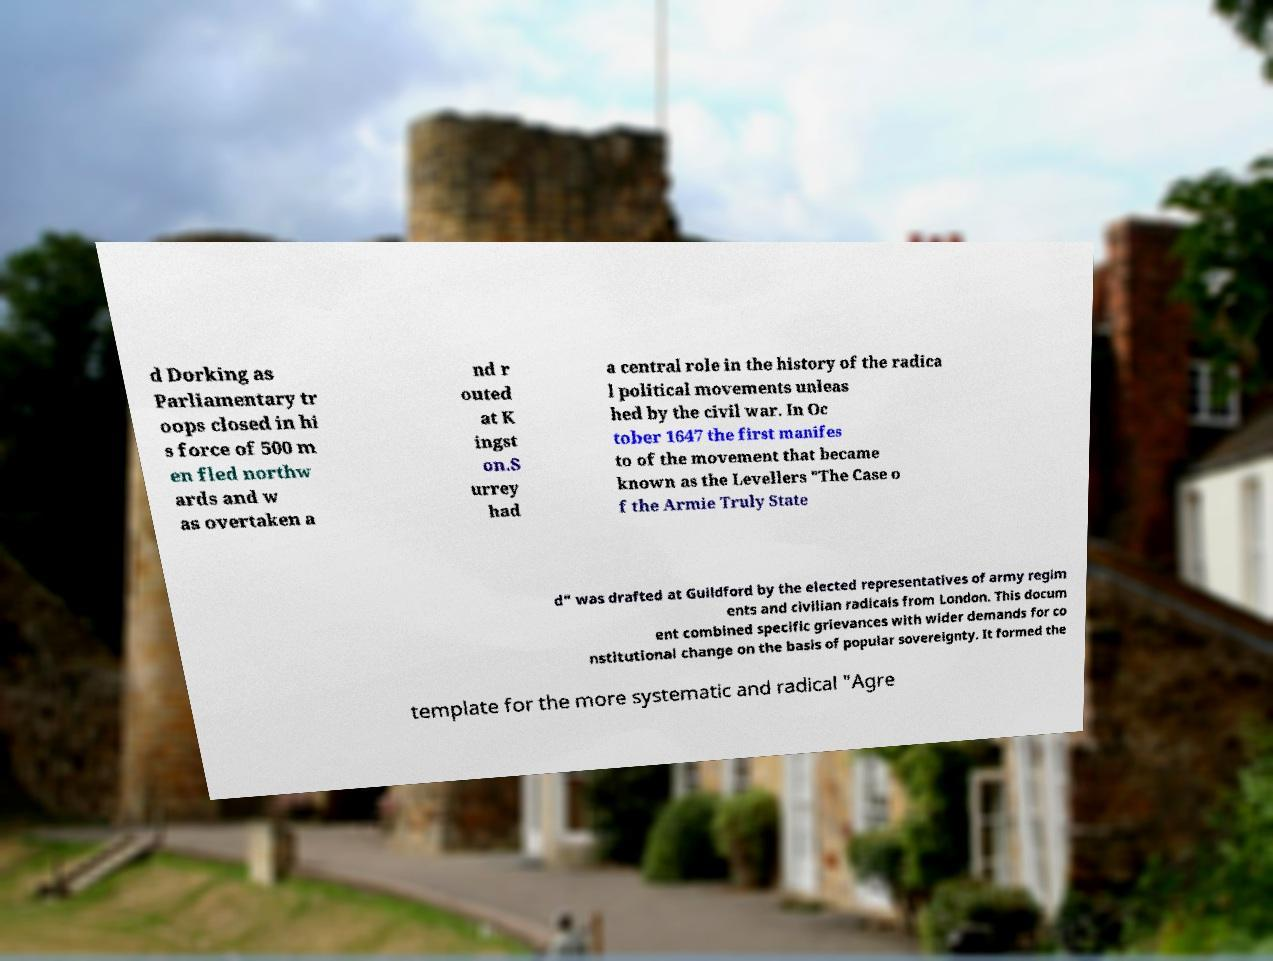Could you extract and type out the text from this image? d Dorking as Parliamentary tr oops closed in hi s force of 500 m en fled northw ards and w as overtaken a nd r outed at K ingst on.S urrey had a central role in the history of the radica l political movements unleas hed by the civil war. In Oc tober 1647 the first manifes to of the movement that became known as the Levellers "The Case o f the Armie Truly State d" was drafted at Guildford by the elected representatives of army regim ents and civilian radicals from London. This docum ent combined specific grievances with wider demands for co nstitutional change on the basis of popular sovereignty. It formed the template for the more systematic and radical "Agre 